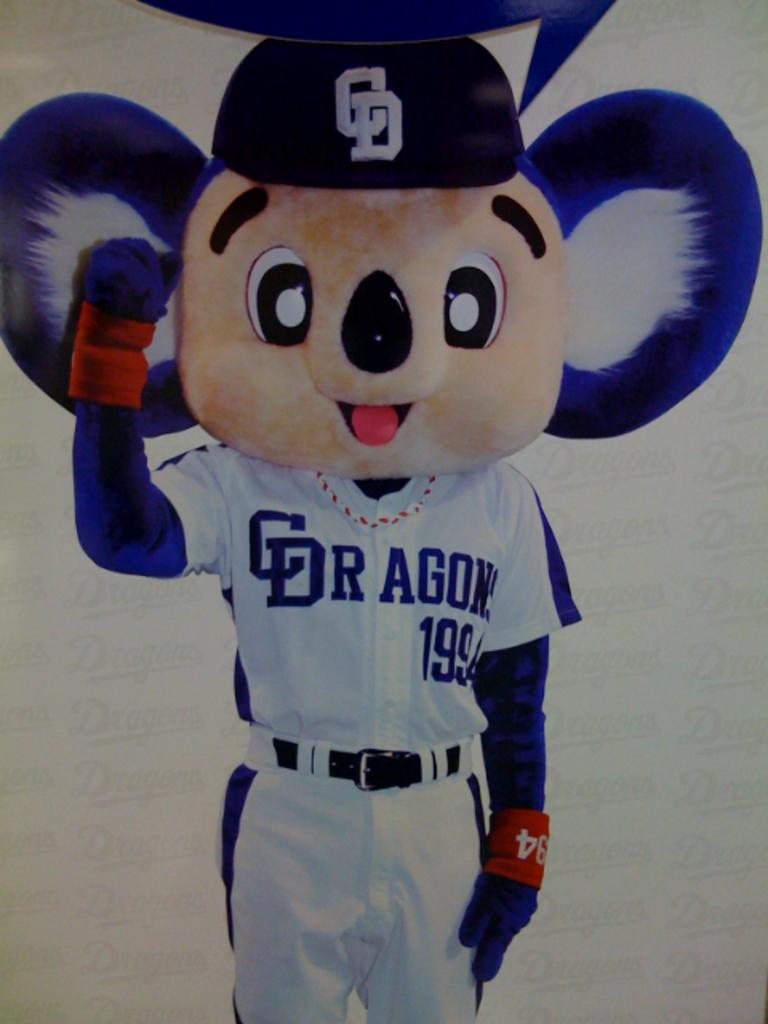<image>
Offer a succinct explanation of the picture presented. a baseball player is wearing a mascot mask with the text c dragons on his chest. 